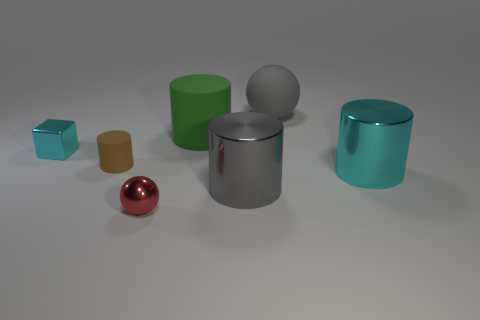Are the cyan block and the tiny red object made of the same material?
Offer a very short reply. Yes. What number of balls are brown things or large matte objects?
Your answer should be compact. 1. There is a small object left of the tiny matte thing; what color is it?
Make the answer very short. Cyan. What number of metallic objects are either cyan cylinders or cylinders?
Offer a very short reply. 2. There is a cyan thing that is to the right of the large gray thing that is in front of the small metal block; what is its material?
Make the answer very short. Metal. What is the material of the object that is the same color as the metal cube?
Make the answer very short. Metal. What color is the metallic cube?
Make the answer very short. Cyan. There is a cyan metal object that is to the right of the gray metal object; is there a large sphere to the right of it?
Your response must be concise. No. What is the green thing made of?
Make the answer very short. Rubber. Do the cyan thing that is left of the small cylinder and the cyan thing on the right side of the big green cylinder have the same material?
Give a very brief answer. Yes. 